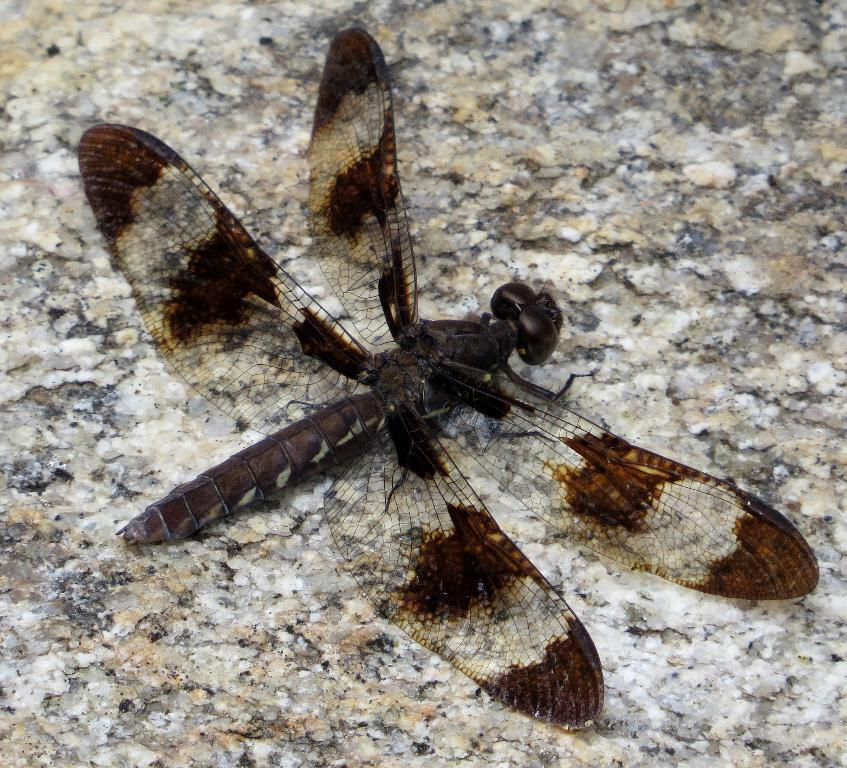What is the main subject of the image? The main subject of the image is a dragonfly. Where is the dragonfly located in the image? The dragonfly is on the granite floor. What type of surprise is the dragonfly holding in the image? There is no indication in the image that the dragonfly is holding any surprise. 